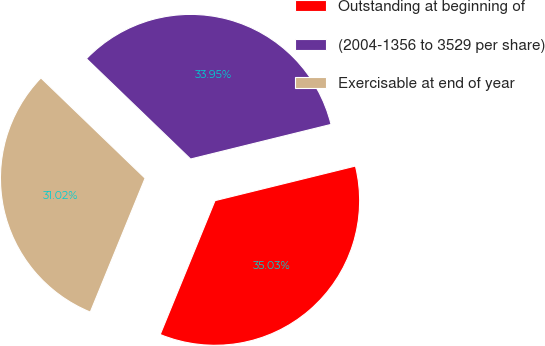<chart> <loc_0><loc_0><loc_500><loc_500><pie_chart><fcel>Outstanding at beginning of<fcel>(2004-1356 to 3529 per share)<fcel>Exercisable at end of year<nl><fcel>35.03%<fcel>33.95%<fcel>31.02%<nl></chart> 